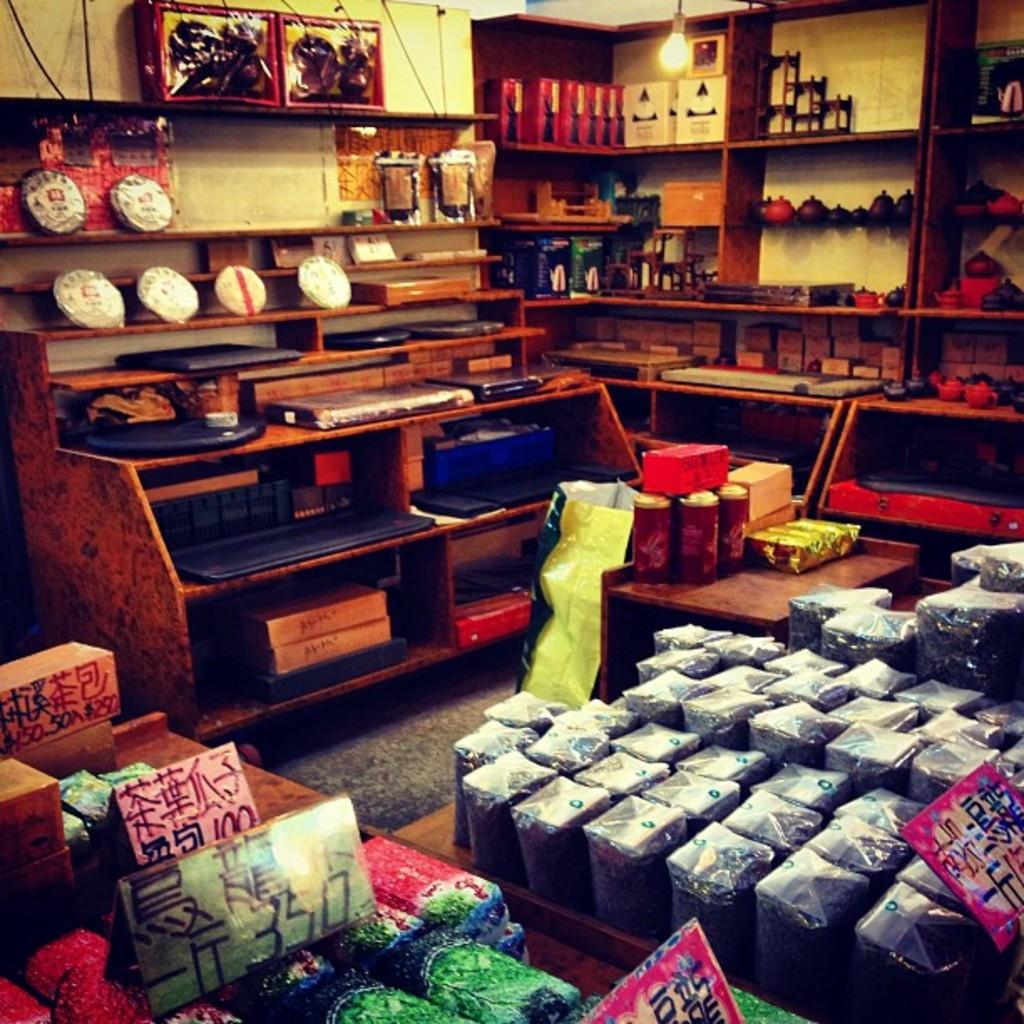<image>
Create a compact narrative representing the image presented. the number 3 is on one of the signs in the store 